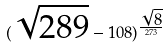<formula> <loc_0><loc_0><loc_500><loc_500>( \sqrt { 2 8 9 } - 1 0 8 ) ^ { \frac { \sqrt { 8 } } { 2 7 3 } }</formula> 